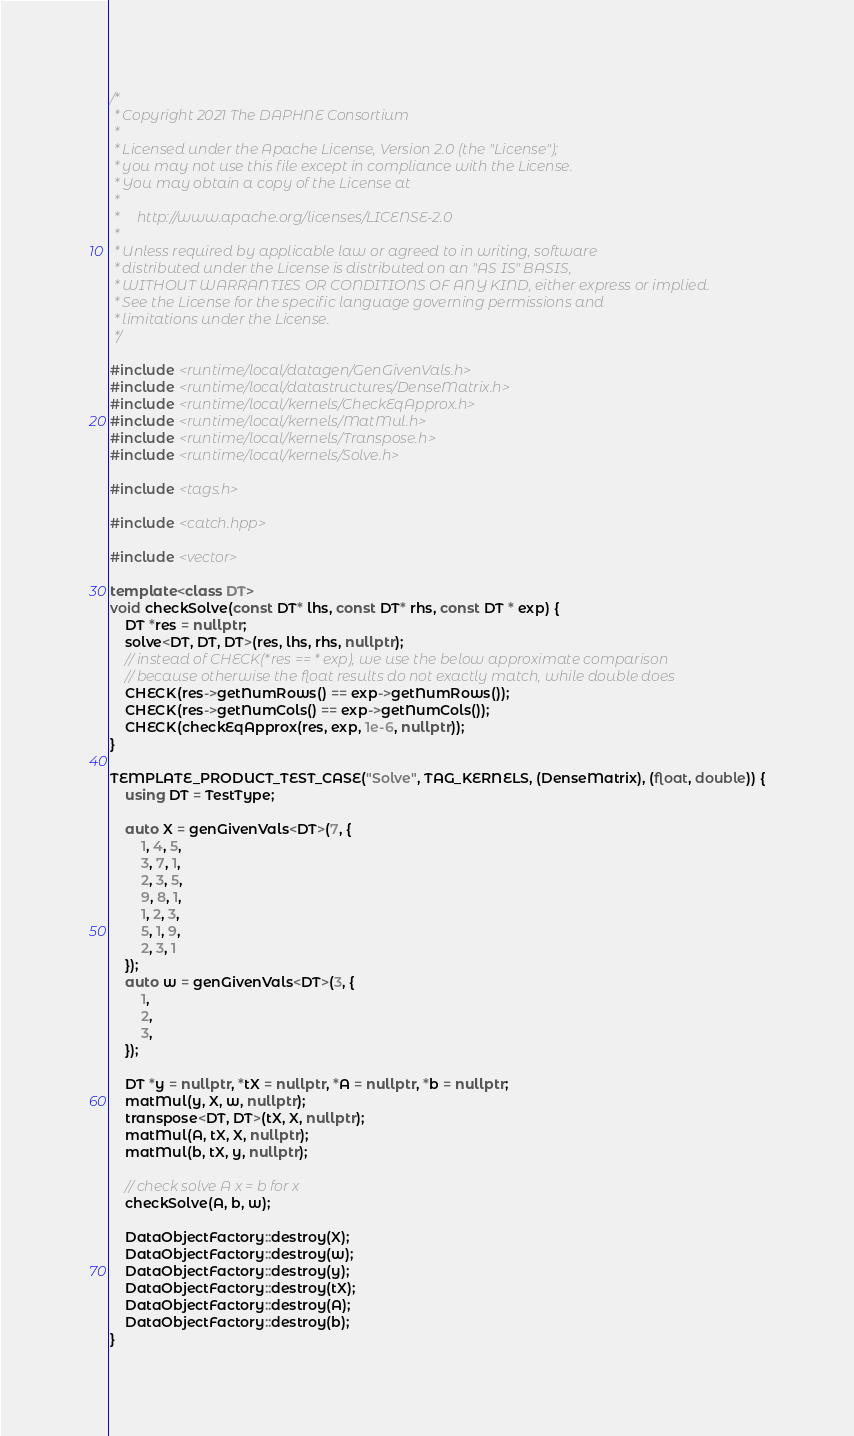<code> <loc_0><loc_0><loc_500><loc_500><_C++_>/*
 * Copyright 2021 The DAPHNE Consortium
 *
 * Licensed under the Apache License, Version 2.0 (the "License");
 * you may not use this file except in compliance with the License.
 * You may obtain a copy of the License at
 *
 *     http://www.apache.org/licenses/LICENSE-2.0
 *
 * Unless required by applicable law or agreed to in writing, software
 * distributed under the License is distributed on an "AS IS" BASIS,
 * WITHOUT WARRANTIES OR CONDITIONS OF ANY KIND, either express or implied.
 * See the License for the specific language governing permissions and
 * limitations under the License.
 */

#include <runtime/local/datagen/GenGivenVals.h>
#include <runtime/local/datastructures/DenseMatrix.h>
#include <runtime/local/kernels/CheckEqApprox.h>
#include <runtime/local/kernels/MatMul.h>
#include <runtime/local/kernels/Transpose.h>
#include <runtime/local/kernels/Solve.h>

#include <tags.h>

#include <catch.hpp>

#include <vector>

template<class DT>
void checkSolve(const DT* lhs, const DT* rhs, const DT * exp) {
    DT *res = nullptr;
    solve<DT, DT, DT>(res, lhs, rhs, nullptr);
    // instead of CHECK(*res == * exp), we use the below approximate comparison
    // because otherwise the float results do not exactly match, while double does
    CHECK(res->getNumRows() == exp->getNumRows());
    CHECK(res->getNumCols() == exp->getNumCols());
    CHECK(checkEqApprox(res, exp, 1e-6, nullptr));
}

TEMPLATE_PRODUCT_TEST_CASE("Solve", TAG_KERNELS, (DenseMatrix), (float, double)) {
    using DT = TestType;
    
    auto X = genGivenVals<DT>(7, {
        1, 4, 5,
        3, 7, 1,
        2, 3, 5,
        9, 8, 1,
        1, 2, 3,
        5, 1, 9,
        2, 3, 1
    });
    auto w = genGivenVals<DT>(3, {
        1,
        2,
        3,
    });

    DT *y = nullptr, *tX = nullptr, *A = nullptr, *b = nullptr;
    matMul(y, X, w, nullptr);
    transpose<DT, DT>(tX, X, nullptr);
    matMul(A, tX, X, nullptr);
    matMul(b, tX, y, nullptr);

    // check solve A x = b for x
    checkSolve(A, b, w);

    DataObjectFactory::destroy(X);
    DataObjectFactory::destroy(w);
    DataObjectFactory::destroy(y);
    DataObjectFactory::destroy(tX);
    DataObjectFactory::destroy(A);
    DataObjectFactory::destroy(b);
}
</code> 